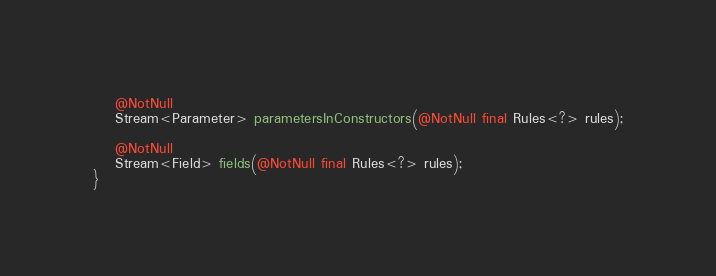Convert code to text. <code><loc_0><loc_0><loc_500><loc_500><_Java_>
    @NotNull
    Stream<Parameter> parametersInConstructors(@NotNull final Rules<?> rules);

    @NotNull
    Stream<Field> fields(@NotNull final Rules<?> rules);
}
</code> 